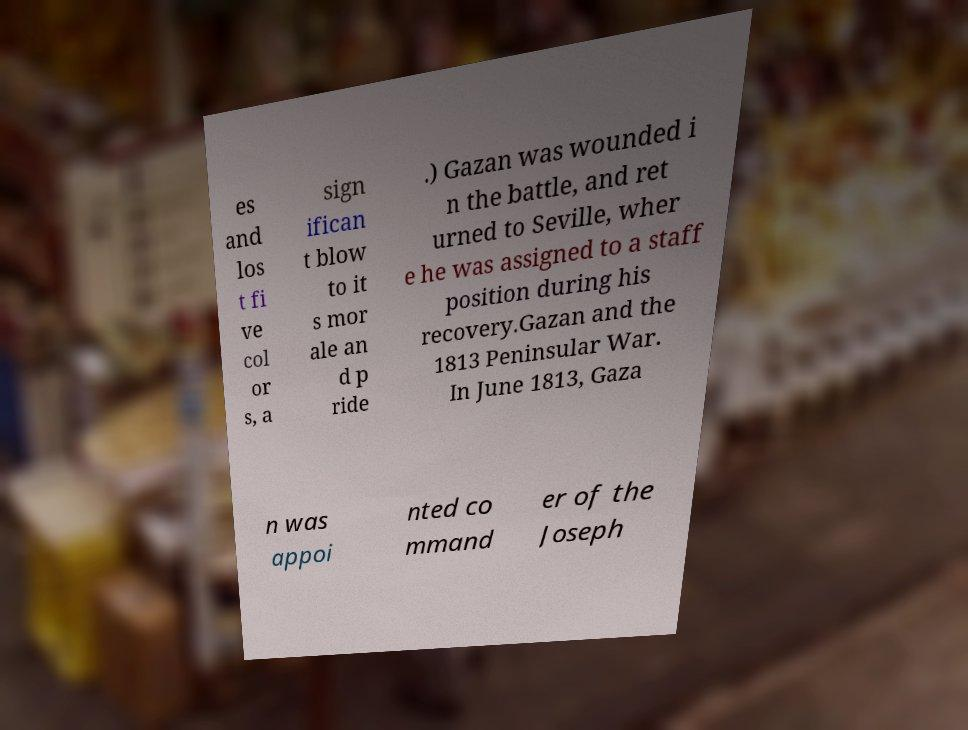Can you accurately transcribe the text from the provided image for me? es and los t fi ve col or s, a sign ifican t blow to it s mor ale an d p ride .) Gazan was wounded i n the battle, and ret urned to Seville, wher e he was assigned to a staff position during his recovery.Gazan and the 1813 Peninsular War. In June 1813, Gaza n was appoi nted co mmand er of the Joseph 